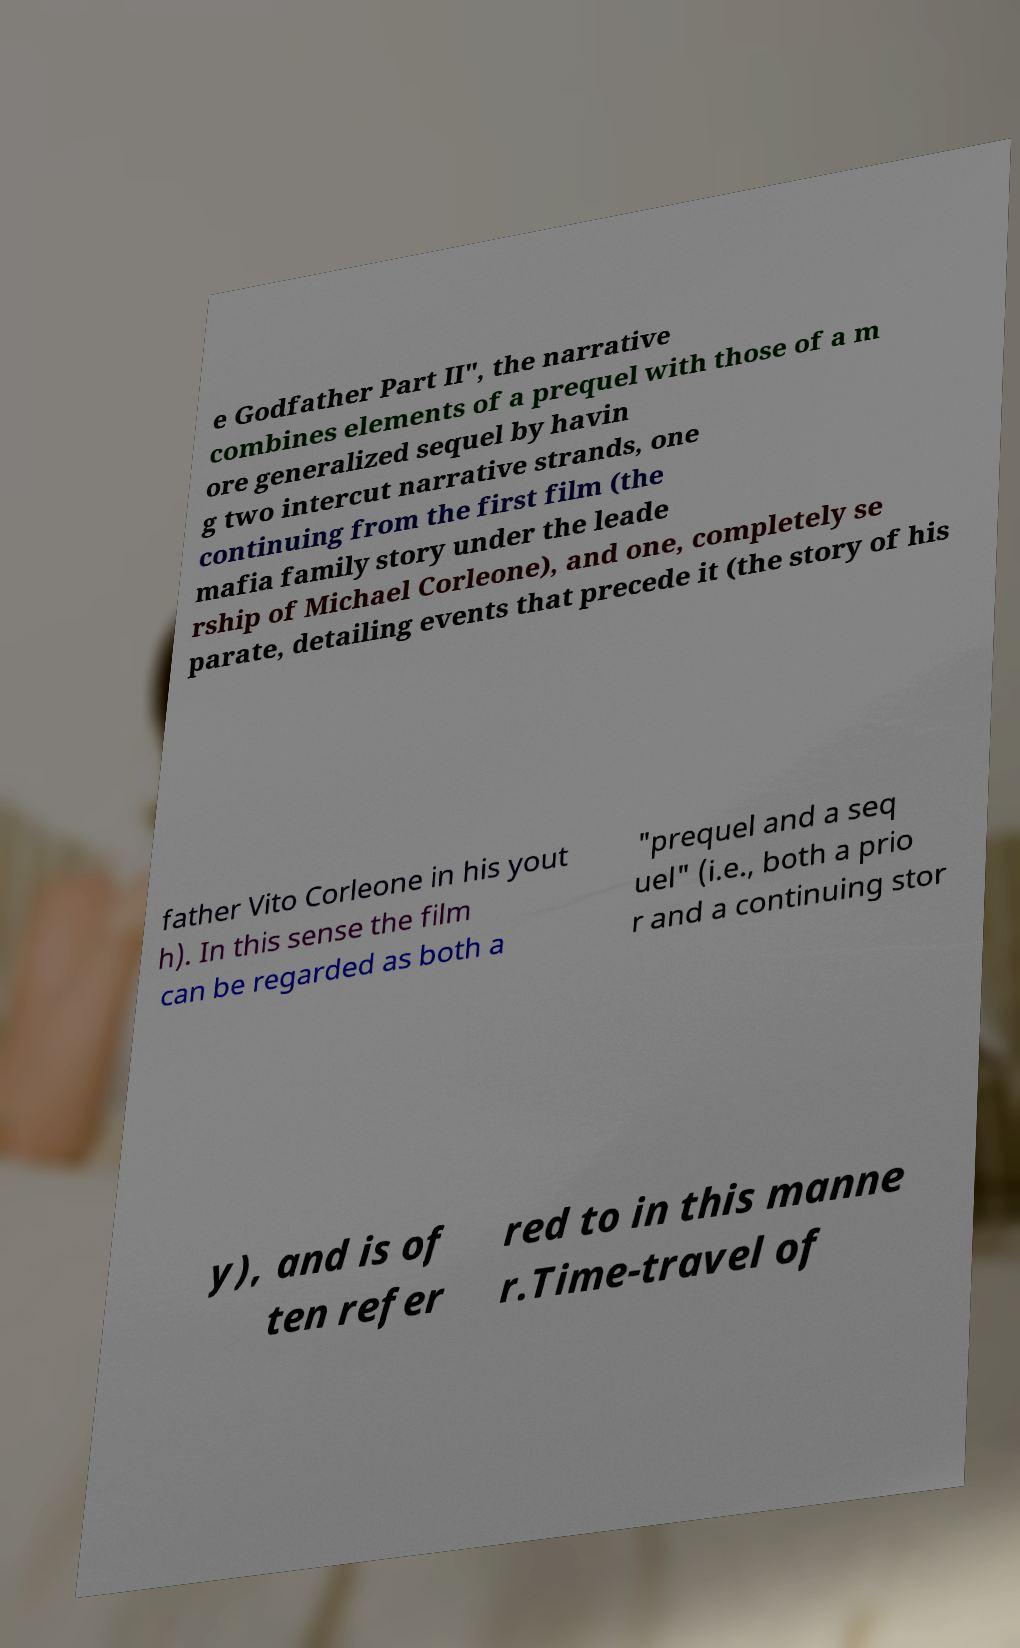For documentation purposes, I need the text within this image transcribed. Could you provide that? e Godfather Part II", the narrative combines elements of a prequel with those of a m ore generalized sequel by havin g two intercut narrative strands, one continuing from the first film (the mafia family story under the leade rship of Michael Corleone), and one, completely se parate, detailing events that precede it (the story of his father Vito Corleone in his yout h). In this sense the film can be regarded as both a "prequel and a seq uel" (i.e., both a prio r and a continuing stor y), and is of ten refer red to in this manne r.Time-travel of 